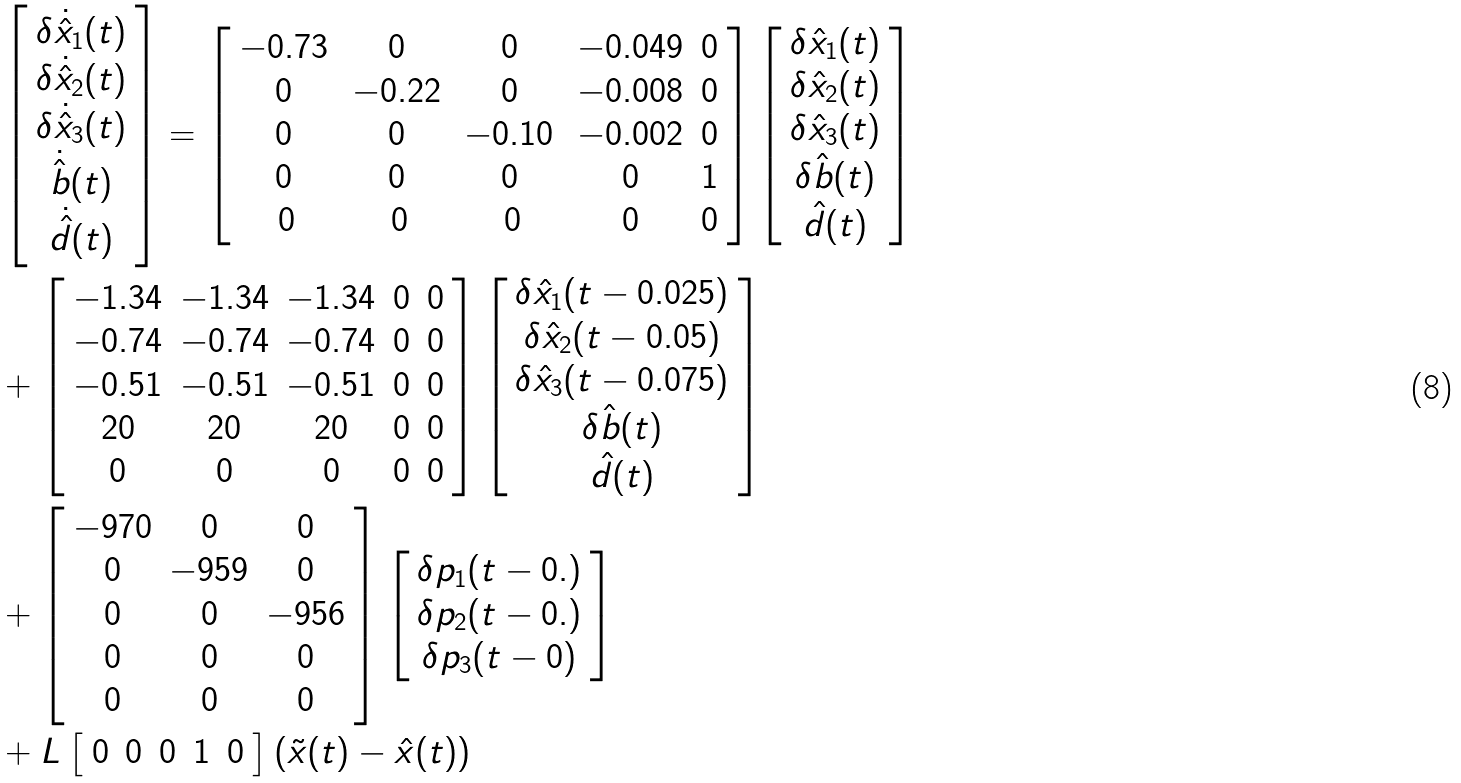<formula> <loc_0><loc_0><loc_500><loc_500>& \left [ \begin{array} { c } \delta \dot { \hat { x } } _ { 1 } ( t ) \\ \delta \dot { \hat { x } } _ { 2 } ( t ) \\ \delta \dot { \hat { x } } _ { 3 } ( t ) \\ \dot { \hat { b } } ( t ) \\ \dot { \hat { d } } ( t ) \end{array} \right ] = \left [ \begin{array} { c c c c c } - 0 . 7 3 \, & 0 \, & 0 \, & - 0 . 0 4 9 & 0 \\ 0 \, & - 0 . 2 2 \, & 0 \, & - 0 . 0 0 8 & 0 \\ 0 \, & 0 \, & - 0 . 1 0 \, & - 0 . 0 0 2 & 0 \\ 0 \, & 0 \, & 0 \, & 0 & 1 \\ 0 & 0 & 0 & 0 & 0 \end{array} \right ] \left [ \begin{array} { c } \delta \hat { x } _ { 1 } ( t ) \\ \delta \hat { x } _ { 2 } ( t ) \\ \delta \hat { x } _ { 3 } ( t ) \\ \delta \hat { b } ( t ) \\ \hat { d } ( t ) \end{array} \right ] \\ & + \left [ \begin{array} { c c c c c } - 1 . 3 4 & - 1 . 3 4 & - 1 . 3 4 & 0 & 0 \\ - 0 . 7 4 & - 0 . 7 4 & - 0 . 7 4 & 0 & 0 \\ - 0 . 5 1 & - 0 . 5 1 & - 0 . 5 1 & 0 & 0 \\ 2 0 & 2 0 & 2 0 & 0 & 0 \\ 0 & 0 & 0 & 0 & 0 \end{array} \right ] \left [ \begin{array} { c } \delta \hat { x } _ { 1 } ( t - 0 . 0 2 5 ) \\ \delta \hat { x } _ { 2 } ( t - 0 . 0 5 ) \\ \delta \hat { x } _ { 3 } ( t - 0 . 0 7 5 ) \\ \delta \hat { b } ( t ) \\ \hat { d } ( t ) \end{array} \right ] \\ & + \left [ \begin{array} { c c c } - 9 7 0 & 0 & 0 \\ 0 & - 9 5 9 & 0 \\ 0 & 0 & - 9 5 6 \\ 0 & 0 & 0 \\ 0 & 0 & 0 \end{array} \right ] \left [ \begin{array} { c } \delta p _ { 1 } ( t - 0 . ) \\ \delta p _ { 2 } ( t - 0 . ) \\ \delta p _ { 3 } ( t - 0 ) \end{array} \right ] \\ & + L \left [ \begin{array} { c c c c c } 0 & 0 & 0 & 1 & 0 \end{array} \right ] \left ( \tilde { x } ( t ) - \hat { x } ( t ) \right )</formula> 